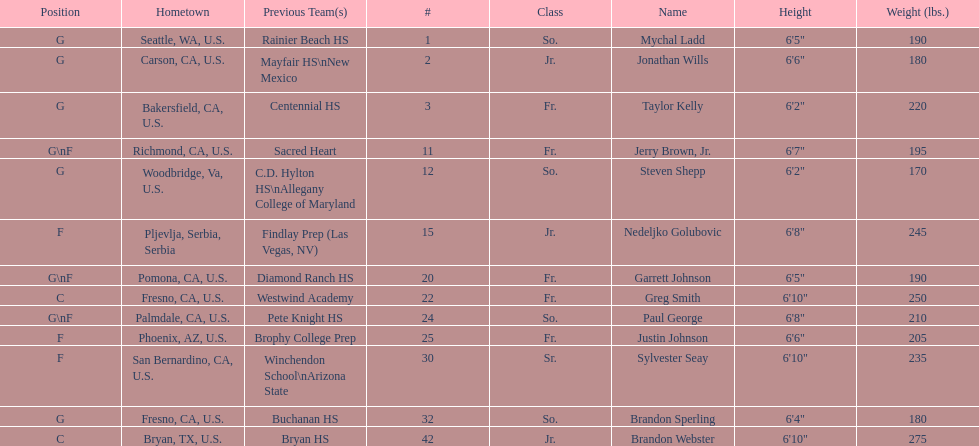Who are the players for the 2009-10 fresno state bulldogs men's basketball team? Mychal Ladd, Jonathan Wills, Taylor Kelly, Jerry Brown, Jr., Steven Shepp, Nedeljko Golubovic, Garrett Johnson, Greg Smith, Paul George, Justin Johnson, Sylvester Seay, Brandon Sperling, Brandon Webster. What are their heights? 6'5", 6'6", 6'2", 6'7", 6'2", 6'8", 6'5", 6'10", 6'8", 6'6", 6'10", 6'4", 6'10". What is the shortest height? 6'2", 6'2". What is the lowest weight? 6'2". Which player is it? Steven Shepp. 